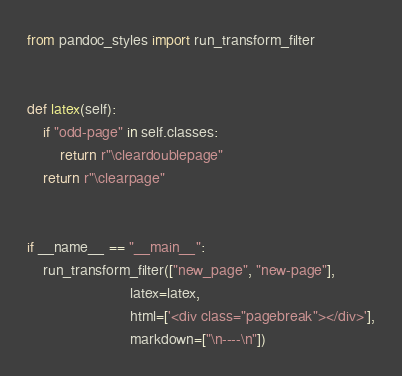Convert code to text. <code><loc_0><loc_0><loc_500><loc_500><_Python_>from pandoc_styles import run_transform_filter


def latex(self):
    if "odd-page" in self.classes:
        return r"\cleardoublepage"
    return r"\clearpage"


if __name__ == "__main__":
    run_transform_filter(["new_page", "new-page"],
                         latex=latex,
                         html=['<div class="pagebreak"></div>'],
                         markdown=["\n----\n"])
</code> 